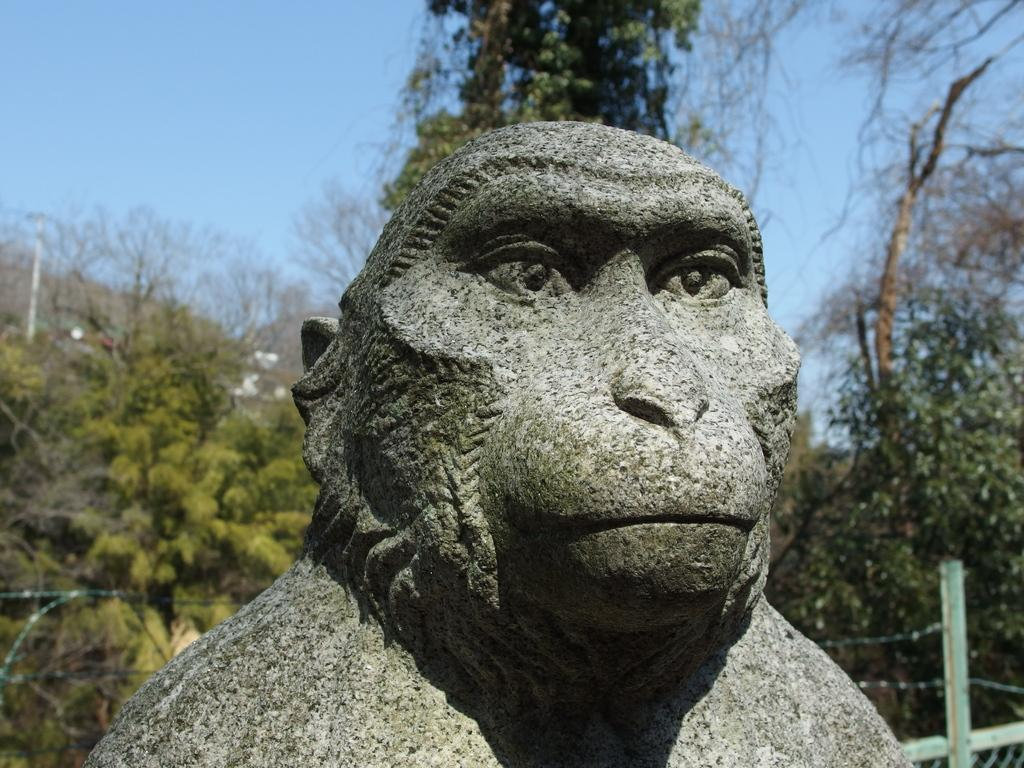What is the main subject of the image? There is a sculpture in the image. What can be seen in the background of the image? There are trees and the sky visible in the background of the image. What type of thumb is being held by the sculpture in the image? There is no thumb present in the image, as it features a sculpture and the background. 